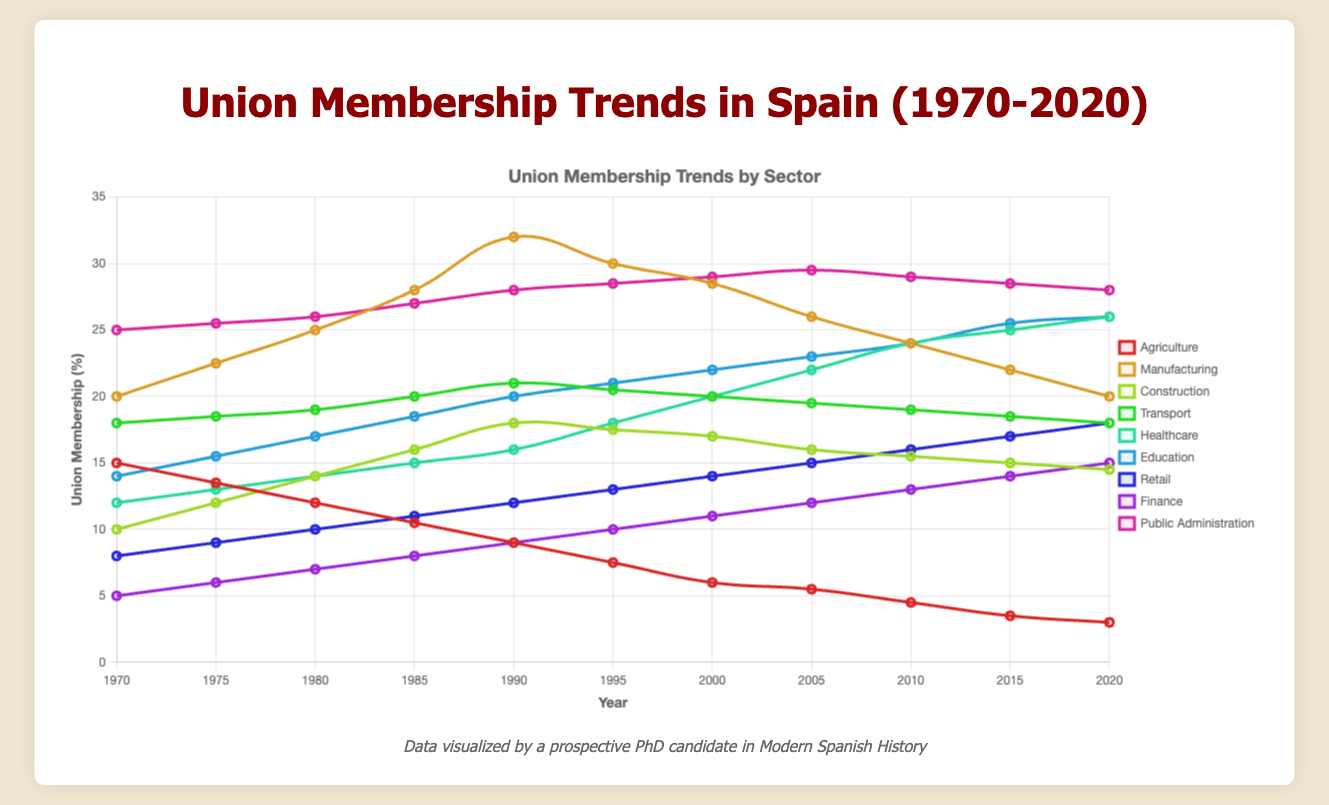Which sector had the highest union membership percentage in 2020? Public Administration had the highest union membership percentage in 2020 at 28.0%. This is determined by checking the membership percentages for each sector in 2020 and identifying the highest value.
Answer: Public Administration How did the union membership percentage in the Agriculture sector change from 1970 to 2020? The union membership in the Agriculture sector decreased from 15.0% in 1970 to 3.0% in 2020. This is calculated by subtracting the 2020 value from the 1970 value (15.0 - 3.0).
Answer: Decreased by 12.0% Between which consecutive years did the Manufacturing sector see its largest increase in union membership percentage? The largest increase in union membership for Manufacturing occurred between 1980 and 1985, where it increased from 25.0% to 28.0%. By looking at the year-to-year changes, this 3.0% increase is the largest.
Answer: 1980-1985 What has been the trend in union membership percentage for the Construction sector from 1970 to 2020? The trend in the Construction sector shows an overall increase from 10.0% in 1970 to 14.5% in 2020. This involves identifying that union membership generally rose, peaking slightly in 1990 before a steady decline to 2020.
Answer: Increasing Which sector experienced the most consistent increase in union membership percentage from 1970 to 2020? The Healthcare sector exhibited the most consistent increase, with union membership growing steadily from 12.0% in 1970 to 26.0% in 2020, without any periods of decline.
Answer: Healthcare Compare the union membership percentage of Finance and Retail sectors in 1990. Which one was higher and by how much? In 1990, Finance had 9.0% and Retail had 12.0%. The Retail sector had a higher union membership percentage by 3.0%, calculated by subtracting Finance's value from Retail’s value.
Answer: Retail by 3.0% What was the average union membership percentage of the Education sector over the entire period (1970-2020)? The average is calculated by summing all the yearly percentages for the Education sector (14.0 + 15.5 + 17.0 + 18.5 + 20.0 + 21.0 + 22.0 + 23.0 + 24.0 + 25.5 + 26.0 = 226.5) and then dividing by the number of years (11). The result is approximately 20.6%.
Answer: 20.6% How did the union membership in the Manufacturing sector in 1995 compare to that in 2005? In 1995, the union membership in Manufacturing was 30.0%, and in 2005, it was 26.0%. Thus, union membership decreased by 4.0%, calculated by subtracting the 2005 value from the 1995 value.
Answer: Decreased by 4.0% Which sector saw a decrease in union membership percentage from 2015 to 2020, and by how much? Public Administration saw a decrease from 28.5% in 2015 to 28.0% in 2020. The decrease is 0.5%, calculated by subtracting the 2020 value from the 2015 value.
Answer: Public Administration by 0.5% What is the difference in union membership percentage between the Healthcare and Public Administration sectors in 2020? In 2020, Healthcare had 26.0% and Public Administration had 28.0%. The difference is 2.0%, calculated by subtracting the Healthcare value from the Public Administration value.
Answer: 2.0% 